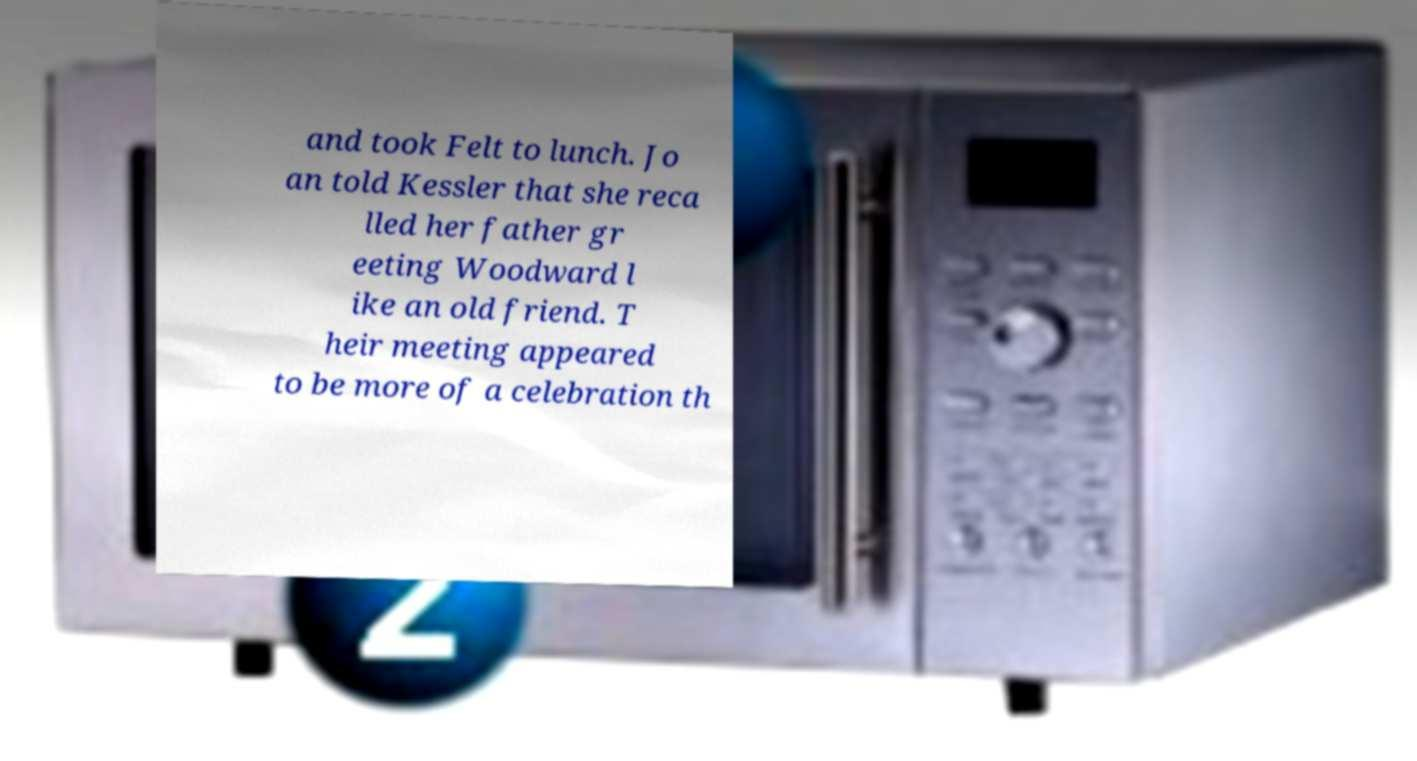Please read and relay the text visible in this image. What does it say? and took Felt to lunch. Jo an told Kessler that she reca lled her father gr eeting Woodward l ike an old friend. T heir meeting appeared to be more of a celebration th 